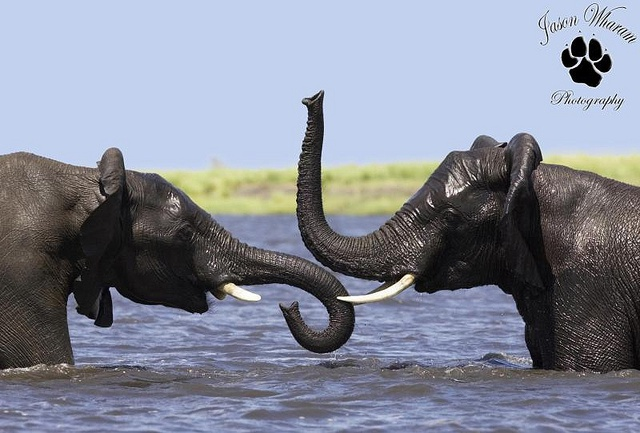Describe the objects in this image and their specific colors. I can see elephant in lavender, black, gray, and darkgray tones and elephant in lavender, black, gray, and darkgray tones in this image. 